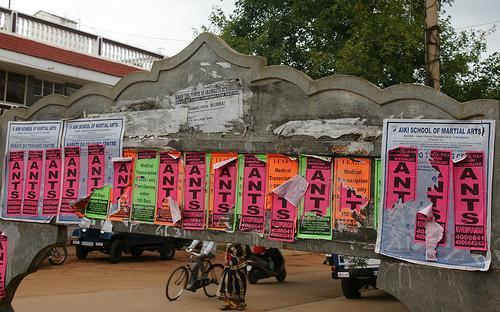How many bears are there?
Give a very brief answer. 0. 